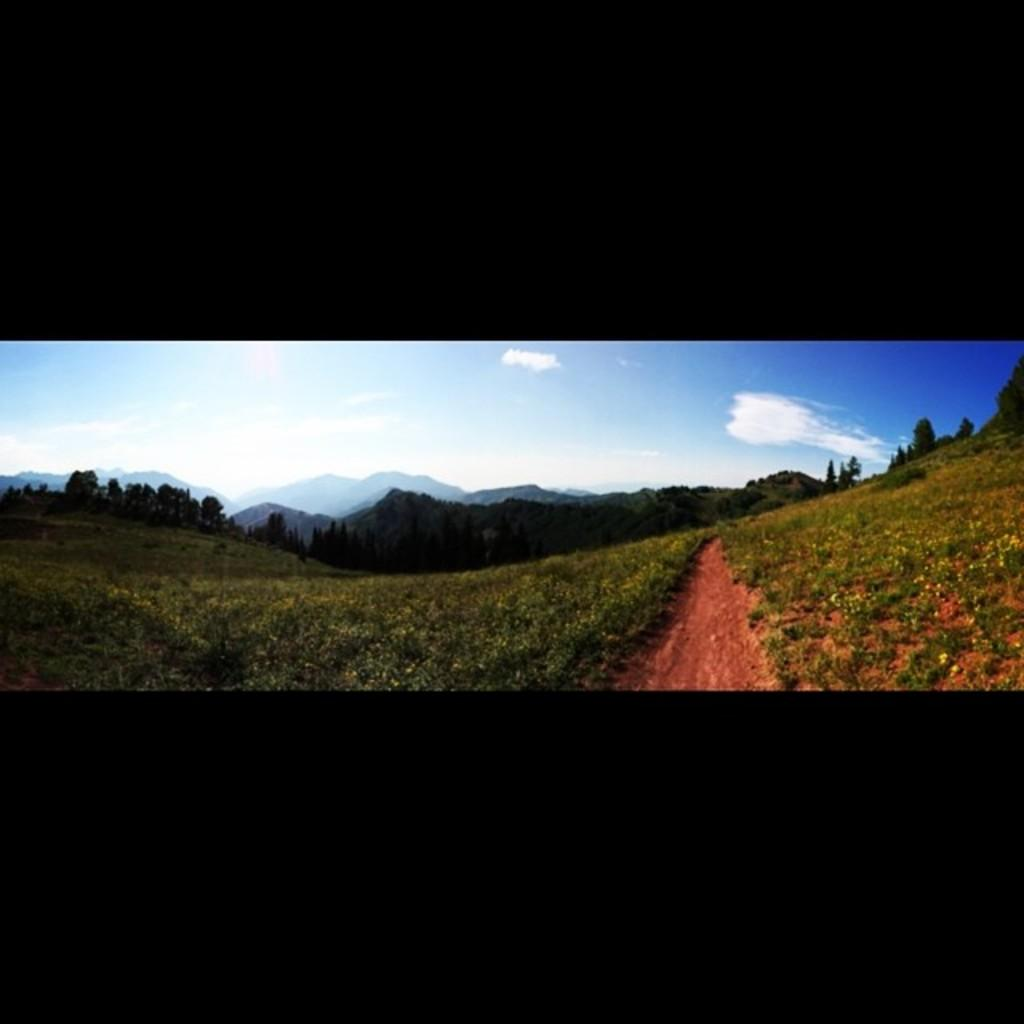What type of plants can be seen in the image? There is a group of plants with flowers in the image. What can be seen in the image besides the plants? There is a pathway visible in the image. What is visible in the background of the image? There is a group of trees and hills visible in the background of the image. How would you describe the sky in the image? The sky is visible in the background of the image, and it appears cloudy. What type of rice is being cooked in the image? There is no rice present in the image; it features a group of plants with flowers, a pathway, trees, hills, and a cloudy sky in the background. How many balls are visible in the image? There are no balls present in the image. 